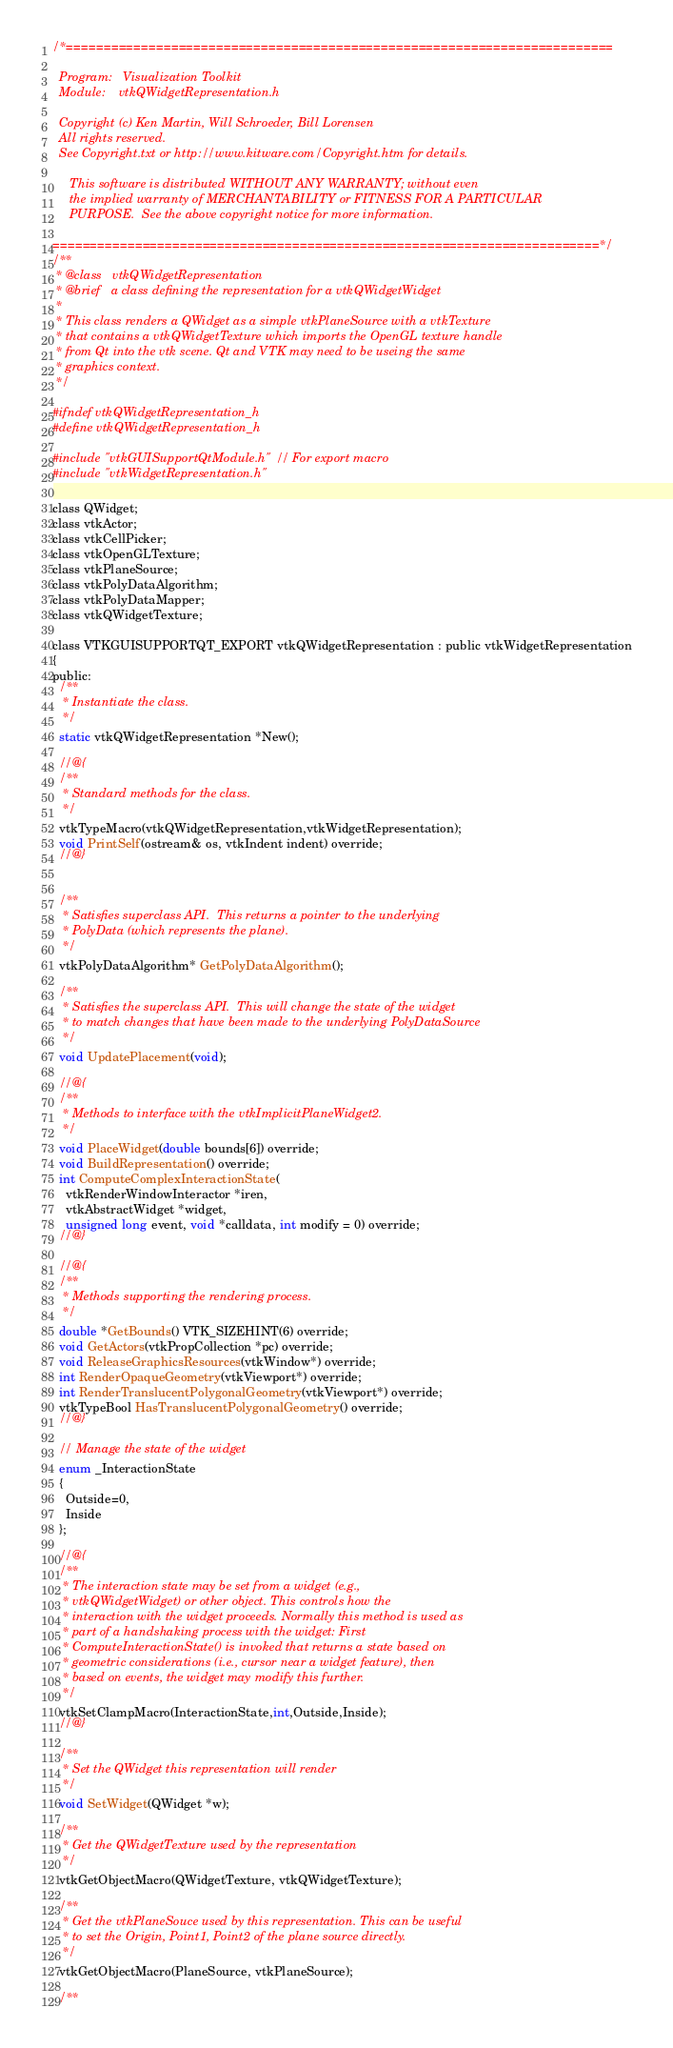<code> <loc_0><loc_0><loc_500><loc_500><_C_>/*=========================================================================

  Program:   Visualization Toolkit
  Module:    vtkQWidgetRepresentation.h

  Copyright (c) Ken Martin, Will Schroeder, Bill Lorensen
  All rights reserved.
  See Copyright.txt or http://www.kitware.com/Copyright.htm for details.

     This software is distributed WITHOUT ANY WARRANTY; without even
     the implied warranty of MERCHANTABILITY or FITNESS FOR A PARTICULAR
     PURPOSE.  See the above copyright notice for more information.

=========================================================================*/
/**
 * @class   vtkQWidgetRepresentation
 * @brief   a class defining the representation for a vtkQWidgetWidget
 *
 * This class renders a QWidget as a simple vtkPlaneSource with a vtkTexture
 * that contains a vtkQWidgetTexture which imports the OpenGL texture handle
 * from Qt into the vtk scene. Qt and VTK may need to be useing the same
 * graphics context.
 */

#ifndef vtkQWidgetRepresentation_h
#define vtkQWidgetRepresentation_h

#include "vtkGUISupportQtModule.h" // For export macro
#include "vtkWidgetRepresentation.h"

class QWidget;
class vtkActor;
class vtkCellPicker;
class vtkOpenGLTexture;
class vtkPlaneSource;
class vtkPolyDataAlgorithm;
class vtkPolyDataMapper;
class vtkQWidgetTexture;

class VTKGUISUPPORTQT_EXPORT vtkQWidgetRepresentation : public vtkWidgetRepresentation
{
public:
  /**
   * Instantiate the class.
   */
  static vtkQWidgetRepresentation *New();

  //@{
  /**
   * Standard methods for the class.
   */
  vtkTypeMacro(vtkQWidgetRepresentation,vtkWidgetRepresentation);
  void PrintSelf(ostream& os, vtkIndent indent) override;
  //@}


  /**
   * Satisfies superclass API.  This returns a pointer to the underlying
   * PolyData (which represents the plane).
   */
  vtkPolyDataAlgorithm* GetPolyDataAlgorithm();

  /**
   * Satisfies the superclass API.  This will change the state of the widget
   * to match changes that have been made to the underlying PolyDataSource
   */
  void UpdatePlacement(void);

  //@{
  /**
   * Methods to interface with the vtkImplicitPlaneWidget2.
   */
  void PlaceWidget(double bounds[6]) override;
  void BuildRepresentation() override;
  int ComputeComplexInteractionState(
    vtkRenderWindowInteractor *iren,
    vtkAbstractWidget *widget,
    unsigned long event, void *calldata, int modify = 0) override;
  //@}

  //@{
  /**
   * Methods supporting the rendering process.
   */
  double *GetBounds() VTK_SIZEHINT(6) override;
  void GetActors(vtkPropCollection *pc) override;
  void ReleaseGraphicsResources(vtkWindow*) override;
  int RenderOpaqueGeometry(vtkViewport*) override;
  int RenderTranslucentPolygonalGeometry(vtkViewport*) override;
  vtkTypeBool HasTranslucentPolygonalGeometry() override;
  //@}

  // Manage the state of the widget
  enum _InteractionState
  {
    Outside=0,
    Inside
  };

  //@{
  /**
   * The interaction state may be set from a widget (e.g.,
   * vtkQWidgetWidget) or other object. This controls how the
   * interaction with the widget proceeds. Normally this method is used as
   * part of a handshaking process with the widget: First
   * ComputeInteractionState() is invoked that returns a state based on
   * geometric considerations (i.e., cursor near a widget feature), then
   * based on events, the widget may modify this further.
   */
  vtkSetClampMacro(InteractionState,int,Outside,Inside);
  //@}

  /**
   * Set the QWidget this representation will render
   */
  void SetWidget(QWidget *w);

  /**
   * Get the QWidgetTexture used by the representation
   */
  vtkGetObjectMacro(QWidgetTexture, vtkQWidgetTexture);

  /**
   * Get the vtkPlaneSouce used by this representation. This can be useful
   * to set the Origin, Point1, Point2 of the plane source directly.
   */
  vtkGetObjectMacro(PlaneSource, vtkPlaneSource);

  /**</code> 